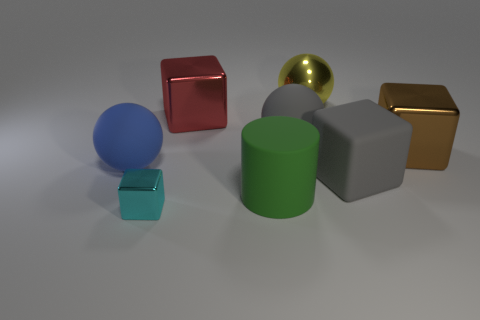Can you describe the textural differences between the objects? Certainly! The objects exhibit a variety of textures: the blue sphere and green cylinder have a smooth and slightly reflective surface, the teal cube and gray cube present matte finishes, and the golden and red cubes have reflective metallic textures. 